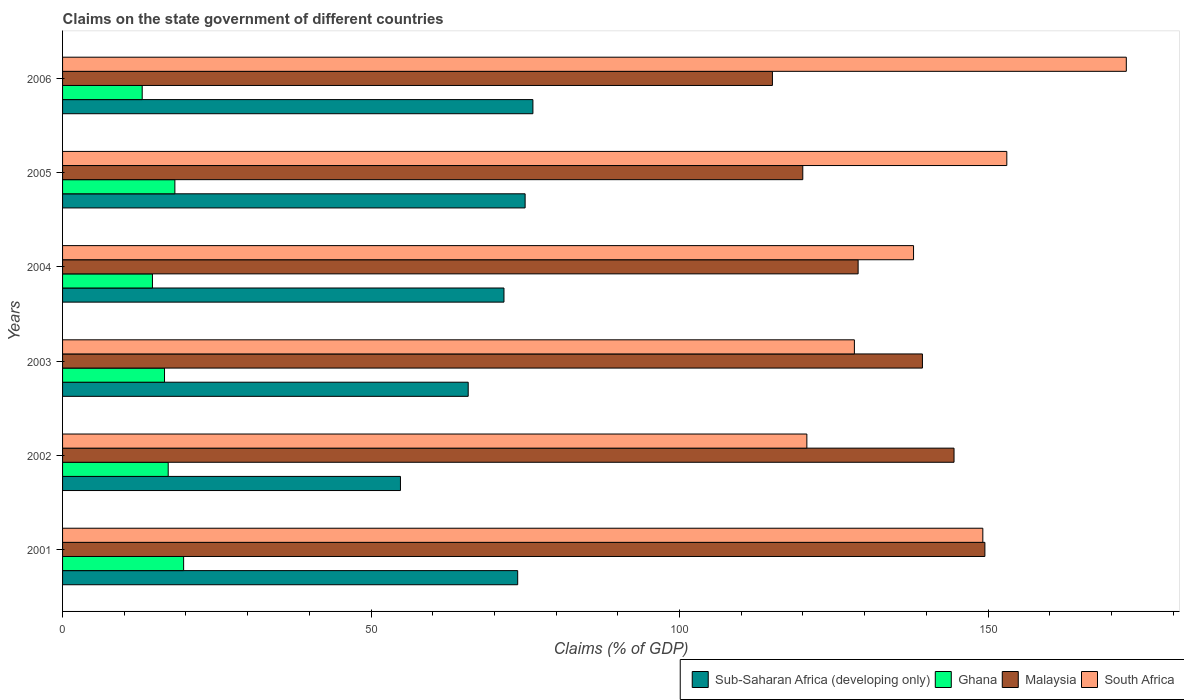Are the number of bars on each tick of the Y-axis equal?
Your answer should be very brief. Yes. How many bars are there on the 5th tick from the bottom?
Offer a terse response. 4. What is the percentage of GDP claimed on the state government in Ghana in 2001?
Your response must be concise. 19.62. Across all years, what is the maximum percentage of GDP claimed on the state government in Sub-Saharan Africa (developing only)?
Your answer should be very brief. 76.23. Across all years, what is the minimum percentage of GDP claimed on the state government in Sub-Saharan Africa (developing only)?
Give a very brief answer. 54.76. In which year was the percentage of GDP claimed on the state government in Sub-Saharan Africa (developing only) minimum?
Keep it short and to the point. 2002. What is the total percentage of GDP claimed on the state government in Sub-Saharan Africa (developing only) in the graph?
Provide a short and direct response. 417.02. What is the difference between the percentage of GDP claimed on the state government in Ghana in 2003 and that in 2004?
Your answer should be compact. 1.96. What is the difference between the percentage of GDP claimed on the state government in Sub-Saharan Africa (developing only) in 2006 and the percentage of GDP claimed on the state government in Malaysia in 2002?
Ensure brevity in your answer.  -68.26. What is the average percentage of GDP claimed on the state government in South Africa per year?
Offer a terse response. 143.58. In the year 2003, what is the difference between the percentage of GDP claimed on the state government in South Africa and percentage of GDP claimed on the state government in Malaysia?
Provide a succinct answer. -11.03. What is the ratio of the percentage of GDP claimed on the state government in Sub-Saharan Africa (developing only) in 2003 to that in 2004?
Make the answer very short. 0.92. Is the percentage of GDP claimed on the state government in Sub-Saharan Africa (developing only) in 2001 less than that in 2002?
Offer a very short reply. No. What is the difference between the highest and the second highest percentage of GDP claimed on the state government in Sub-Saharan Africa (developing only)?
Your answer should be compact. 1.26. What is the difference between the highest and the lowest percentage of GDP claimed on the state government in Ghana?
Your answer should be compact. 6.71. Is it the case that in every year, the sum of the percentage of GDP claimed on the state government in Malaysia and percentage of GDP claimed on the state government in South Africa is greater than the sum of percentage of GDP claimed on the state government in Ghana and percentage of GDP claimed on the state government in Sub-Saharan Africa (developing only)?
Give a very brief answer. No. What does the 1st bar from the top in 2002 represents?
Your answer should be compact. South Africa. What does the 4th bar from the bottom in 2004 represents?
Make the answer very short. South Africa. How many years are there in the graph?
Offer a terse response. 6. Where does the legend appear in the graph?
Ensure brevity in your answer.  Bottom right. How many legend labels are there?
Provide a short and direct response. 4. How are the legend labels stacked?
Your answer should be compact. Horizontal. What is the title of the graph?
Your answer should be very brief. Claims on the state government of different countries. Does "Moldova" appear as one of the legend labels in the graph?
Keep it short and to the point. No. What is the label or title of the X-axis?
Offer a very short reply. Claims (% of GDP). What is the label or title of the Y-axis?
Provide a succinct answer. Years. What is the Claims (% of GDP) in Sub-Saharan Africa (developing only) in 2001?
Provide a succinct answer. 73.77. What is the Claims (% of GDP) in Ghana in 2001?
Offer a terse response. 19.62. What is the Claims (% of GDP) of Malaysia in 2001?
Ensure brevity in your answer.  149.49. What is the Claims (% of GDP) of South Africa in 2001?
Make the answer very short. 149.15. What is the Claims (% of GDP) in Sub-Saharan Africa (developing only) in 2002?
Offer a terse response. 54.76. What is the Claims (% of GDP) of Ghana in 2002?
Provide a short and direct response. 17.12. What is the Claims (% of GDP) in Malaysia in 2002?
Your answer should be very brief. 144.49. What is the Claims (% of GDP) of South Africa in 2002?
Offer a very short reply. 120.63. What is the Claims (% of GDP) in Sub-Saharan Africa (developing only) in 2003?
Offer a very short reply. 65.75. What is the Claims (% of GDP) of Ghana in 2003?
Provide a succinct answer. 16.52. What is the Claims (% of GDP) in Malaysia in 2003?
Your response must be concise. 139.37. What is the Claims (% of GDP) of South Africa in 2003?
Give a very brief answer. 128.34. What is the Claims (% of GDP) in Sub-Saharan Africa (developing only) in 2004?
Your answer should be compact. 71.54. What is the Claims (% of GDP) of Ghana in 2004?
Your answer should be very brief. 14.57. What is the Claims (% of GDP) of Malaysia in 2004?
Ensure brevity in your answer.  128.94. What is the Claims (% of GDP) of South Africa in 2004?
Your answer should be compact. 137.93. What is the Claims (% of GDP) of Sub-Saharan Africa (developing only) in 2005?
Your response must be concise. 74.97. What is the Claims (% of GDP) in Ghana in 2005?
Your response must be concise. 18.2. What is the Claims (% of GDP) of Malaysia in 2005?
Your answer should be very brief. 119.97. What is the Claims (% of GDP) of South Africa in 2005?
Offer a very short reply. 153.04. What is the Claims (% of GDP) in Sub-Saharan Africa (developing only) in 2006?
Your response must be concise. 76.23. What is the Claims (% of GDP) in Ghana in 2006?
Ensure brevity in your answer.  12.91. What is the Claims (% of GDP) of Malaysia in 2006?
Offer a very short reply. 115.05. What is the Claims (% of GDP) in South Africa in 2006?
Keep it short and to the point. 172.41. Across all years, what is the maximum Claims (% of GDP) in Sub-Saharan Africa (developing only)?
Provide a short and direct response. 76.23. Across all years, what is the maximum Claims (% of GDP) in Ghana?
Your answer should be compact. 19.62. Across all years, what is the maximum Claims (% of GDP) of Malaysia?
Ensure brevity in your answer.  149.49. Across all years, what is the maximum Claims (% of GDP) of South Africa?
Offer a very short reply. 172.41. Across all years, what is the minimum Claims (% of GDP) of Sub-Saharan Africa (developing only)?
Make the answer very short. 54.76. Across all years, what is the minimum Claims (% of GDP) in Ghana?
Make the answer very short. 12.91. Across all years, what is the minimum Claims (% of GDP) in Malaysia?
Keep it short and to the point. 115.05. Across all years, what is the minimum Claims (% of GDP) in South Africa?
Ensure brevity in your answer.  120.63. What is the total Claims (% of GDP) in Sub-Saharan Africa (developing only) in the graph?
Give a very brief answer. 417.02. What is the total Claims (% of GDP) in Ghana in the graph?
Your answer should be compact. 98.95. What is the total Claims (% of GDP) in Malaysia in the graph?
Ensure brevity in your answer.  797.31. What is the total Claims (% of GDP) of South Africa in the graph?
Give a very brief answer. 861.5. What is the difference between the Claims (% of GDP) in Sub-Saharan Africa (developing only) in 2001 and that in 2002?
Make the answer very short. 19. What is the difference between the Claims (% of GDP) in Ghana in 2001 and that in 2002?
Give a very brief answer. 2.5. What is the difference between the Claims (% of GDP) of Malaysia in 2001 and that in 2002?
Offer a terse response. 5. What is the difference between the Claims (% of GDP) in South Africa in 2001 and that in 2002?
Give a very brief answer. 28.52. What is the difference between the Claims (% of GDP) of Sub-Saharan Africa (developing only) in 2001 and that in 2003?
Provide a succinct answer. 8.02. What is the difference between the Claims (% of GDP) in Ghana in 2001 and that in 2003?
Your answer should be compact. 3.1. What is the difference between the Claims (% of GDP) in Malaysia in 2001 and that in 2003?
Provide a short and direct response. 10.12. What is the difference between the Claims (% of GDP) in South Africa in 2001 and that in 2003?
Your answer should be compact. 20.82. What is the difference between the Claims (% of GDP) in Sub-Saharan Africa (developing only) in 2001 and that in 2004?
Give a very brief answer. 2.22. What is the difference between the Claims (% of GDP) of Ghana in 2001 and that in 2004?
Give a very brief answer. 5.05. What is the difference between the Claims (% of GDP) in Malaysia in 2001 and that in 2004?
Provide a short and direct response. 20.55. What is the difference between the Claims (% of GDP) in South Africa in 2001 and that in 2004?
Your answer should be compact. 11.23. What is the difference between the Claims (% of GDP) of Sub-Saharan Africa (developing only) in 2001 and that in 2005?
Provide a short and direct response. -1.2. What is the difference between the Claims (% of GDP) of Ghana in 2001 and that in 2005?
Make the answer very short. 1.42. What is the difference between the Claims (% of GDP) of Malaysia in 2001 and that in 2005?
Your answer should be compact. 29.52. What is the difference between the Claims (% of GDP) in South Africa in 2001 and that in 2005?
Your answer should be very brief. -3.89. What is the difference between the Claims (% of GDP) in Sub-Saharan Africa (developing only) in 2001 and that in 2006?
Make the answer very short. -2.47. What is the difference between the Claims (% of GDP) in Ghana in 2001 and that in 2006?
Make the answer very short. 6.71. What is the difference between the Claims (% of GDP) of Malaysia in 2001 and that in 2006?
Keep it short and to the point. 34.44. What is the difference between the Claims (% of GDP) in South Africa in 2001 and that in 2006?
Your answer should be very brief. -23.26. What is the difference between the Claims (% of GDP) in Sub-Saharan Africa (developing only) in 2002 and that in 2003?
Provide a succinct answer. -10.98. What is the difference between the Claims (% of GDP) in Ghana in 2002 and that in 2003?
Keep it short and to the point. 0.6. What is the difference between the Claims (% of GDP) of Malaysia in 2002 and that in 2003?
Your answer should be very brief. 5.12. What is the difference between the Claims (% of GDP) in South Africa in 2002 and that in 2003?
Your answer should be compact. -7.7. What is the difference between the Claims (% of GDP) in Sub-Saharan Africa (developing only) in 2002 and that in 2004?
Give a very brief answer. -16.78. What is the difference between the Claims (% of GDP) of Ghana in 2002 and that in 2004?
Your answer should be very brief. 2.55. What is the difference between the Claims (% of GDP) in Malaysia in 2002 and that in 2004?
Ensure brevity in your answer.  15.54. What is the difference between the Claims (% of GDP) in South Africa in 2002 and that in 2004?
Provide a short and direct response. -17.29. What is the difference between the Claims (% of GDP) of Sub-Saharan Africa (developing only) in 2002 and that in 2005?
Keep it short and to the point. -20.21. What is the difference between the Claims (% of GDP) of Ghana in 2002 and that in 2005?
Make the answer very short. -1.08. What is the difference between the Claims (% of GDP) in Malaysia in 2002 and that in 2005?
Your answer should be compact. 24.52. What is the difference between the Claims (% of GDP) of South Africa in 2002 and that in 2005?
Make the answer very short. -32.41. What is the difference between the Claims (% of GDP) in Sub-Saharan Africa (developing only) in 2002 and that in 2006?
Offer a terse response. -21.47. What is the difference between the Claims (% of GDP) of Ghana in 2002 and that in 2006?
Provide a short and direct response. 4.21. What is the difference between the Claims (% of GDP) of Malaysia in 2002 and that in 2006?
Provide a succinct answer. 29.44. What is the difference between the Claims (% of GDP) of South Africa in 2002 and that in 2006?
Your answer should be compact. -51.77. What is the difference between the Claims (% of GDP) of Sub-Saharan Africa (developing only) in 2003 and that in 2004?
Offer a very short reply. -5.8. What is the difference between the Claims (% of GDP) of Ghana in 2003 and that in 2004?
Ensure brevity in your answer.  1.96. What is the difference between the Claims (% of GDP) in Malaysia in 2003 and that in 2004?
Your answer should be very brief. 10.42. What is the difference between the Claims (% of GDP) in South Africa in 2003 and that in 2004?
Your answer should be compact. -9.59. What is the difference between the Claims (% of GDP) of Sub-Saharan Africa (developing only) in 2003 and that in 2005?
Provide a short and direct response. -9.22. What is the difference between the Claims (% of GDP) of Ghana in 2003 and that in 2005?
Give a very brief answer. -1.68. What is the difference between the Claims (% of GDP) of Malaysia in 2003 and that in 2005?
Ensure brevity in your answer.  19.39. What is the difference between the Claims (% of GDP) in South Africa in 2003 and that in 2005?
Give a very brief answer. -24.7. What is the difference between the Claims (% of GDP) of Sub-Saharan Africa (developing only) in 2003 and that in 2006?
Your answer should be very brief. -10.49. What is the difference between the Claims (% of GDP) in Ghana in 2003 and that in 2006?
Provide a short and direct response. 3.62. What is the difference between the Claims (% of GDP) in Malaysia in 2003 and that in 2006?
Ensure brevity in your answer.  24.31. What is the difference between the Claims (% of GDP) of South Africa in 2003 and that in 2006?
Offer a very short reply. -44.07. What is the difference between the Claims (% of GDP) in Sub-Saharan Africa (developing only) in 2004 and that in 2005?
Give a very brief answer. -3.43. What is the difference between the Claims (% of GDP) of Ghana in 2004 and that in 2005?
Provide a short and direct response. -3.63. What is the difference between the Claims (% of GDP) in Malaysia in 2004 and that in 2005?
Your response must be concise. 8.97. What is the difference between the Claims (% of GDP) in South Africa in 2004 and that in 2005?
Ensure brevity in your answer.  -15.12. What is the difference between the Claims (% of GDP) in Sub-Saharan Africa (developing only) in 2004 and that in 2006?
Make the answer very short. -4.69. What is the difference between the Claims (% of GDP) of Ghana in 2004 and that in 2006?
Your answer should be compact. 1.66. What is the difference between the Claims (% of GDP) of Malaysia in 2004 and that in 2006?
Your answer should be very brief. 13.89. What is the difference between the Claims (% of GDP) in South Africa in 2004 and that in 2006?
Your answer should be very brief. -34.48. What is the difference between the Claims (% of GDP) of Sub-Saharan Africa (developing only) in 2005 and that in 2006?
Provide a short and direct response. -1.26. What is the difference between the Claims (% of GDP) of Ghana in 2005 and that in 2006?
Your answer should be compact. 5.3. What is the difference between the Claims (% of GDP) in Malaysia in 2005 and that in 2006?
Ensure brevity in your answer.  4.92. What is the difference between the Claims (% of GDP) of South Africa in 2005 and that in 2006?
Keep it short and to the point. -19.37. What is the difference between the Claims (% of GDP) of Sub-Saharan Africa (developing only) in 2001 and the Claims (% of GDP) of Ghana in 2002?
Make the answer very short. 56.64. What is the difference between the Claims (% of GDP) of Sub-Saharan Africa (developing only) in 2001 and the Claims (% of GDP) of Malaysia in 2002?
Make the answer very short. -70.72. What is the difference between the Claims (% of GDP) of Sub-Saharan Africa (developing only) in 2001 and the Claims (% of GDP) of South Africa in 2002?
Offer a very short reply. -46.87. What is the difference between the Claims (% of GDP) of Ghana in 2001 and the Claims (% of GDP) of Malaysia in 2002?
Offer a terse response. -124.87. What is the difference between the Claims (% of GDP) of Ghana in 2001 and the Claims (% of GDP) of South Africa in 2002?
Provide a succinct answer. -101.01. What is the difference between the Claims (% of GDP) in Malaysia in 2001 and the Claims (% of GDP) in South Africa in 2002?
Your answer should be compact. 28.85. What is the difference between the Claims (% of GDP) of Sub-Saharan Africa (developing only) in 2001 and the Claims (% of GDP) of Ghana in 2003?
Your answer should be compact. 57.24. What is the difference between the Claims (% of GDP) in Sub-Saharan Africa (developing only) in 2001 and the Claims (% of GDP) in Malaysia in 2003?
Provide a succinct answer. -65.6. What is the difference between the Claims (% of GDP) of Sub-Saharan Africa (developing only) in 2001 and the Claims (% of GDP) of South Africa in 2003?
Give a very brief answer. -54.57. What is the difference between the Claims (% of GDP) of Ghana in 2001 and the Claims (% of GDP) of Malaysia in 2003?
Keep it short and to the point. -119.75. What is the difference between the Claims (% of GDP) in Ghana in 2001 and the Claims (% of GDP) in South Africa in 2003?
Make the answer very short. -108.72. What is the difference between the Claims (% of GDP) of Malaysia in 2001 and the Claims (% of GDP) of South Africa in 2003?
Make the answer very short. 21.15. What is the difference between the Claims (% of GDP) in Sub-Saharan Africa (developing only) in 2001 and the Claims (% of GDP) in Ghana in 2004?
Give a very brief answer. 59.2. What is the difference between the Claims (% of GDP) of Sub-Saharan Africa (developing only) in 2001 and the Claims (% of GDP) of Malaysia in 2004?
Your response must be concise. -55.18. What is the difference between the Claims (% of GDP) of Sub-Saharan Africa (developing only) in 2001 and the Claims (% of GDP) of South Africa in 2004?
Keep it short and to the point. -64.16. What is the difference between the Claims (% of GDP) in Ghana in 2001 and the Claims (% of GDP) in Malaysia in 2004?
Offer a very short reply. -109.32. What is the difference between the Claims (% of GDP) in Ghana in 2001 and the Claims (% of GDP) in South Africa in 2004?
Offer a very short reply. -118.31. What is the difference between the Claims (% of GDP) in Malaysia in 2001 and the Claims (% of GDP) in South Africa in 2004?
Provide a short and direct response. 11.56. What is the difference between the Claims (% of GDP) of Sub-Saharan Africa (developing only) in 2001 and the Claims (% of GDP) of Ghana in 2005?
Your answer should be compact. 55.56. What is the difference between the Claims (% of GDP) of Sub-Saharan Africa (developing only) in 2001 and the Claims (% of GDP) of Malaysia in 2005?
Make the answer very short. -46.21. What is the difference between the Claims (% of GDP) of Sub-Saharan Africa (developing only) in 2001 and the Claims (% of GDP) of South Africa in 2005?
Ensure brevity in your answer.  -79.28. What is the difference between the Claims (% of GDP) in Ghana in 2001 and the Claims (% of GDP) in Malaysia in 2005?
Your answer should be compact. -100.35. What is the difference between the Claims (% of GDP) in Ghana in 2001 and the Claims (% of GDP) in South Africa in 2005?
Provide a short and direct response. -133.42. What is the difference between the Claims (% of GDP) in Malaysia in 2001 and the Claims (% of GDP) in South Africa in 2005?
Provide a short and direct response. -3.55. What is the difference between the Claims (% of GDP) of Sub-Saharan Africa (developing only) in 2001 and the Claims (% of GDP) of Ghana in 2006?
Your response must be concise. 60.86. What is the difference between the Claims (% of GDP) of Sub-Saharan Africa (developing only) in 2001 and the Claims (% of GDP) of Malaysia in 2006?
Keep it short and to the point. -41.29. What is the difference between the Claims (% of GDP) in Sub-Saharan Africa (developing only) in 2001 and the Claims (% of GDP) in South Africa in 2006?
Make the answer very short. -98.64. What is the difference between the Claims (% of GDP) in Ghana in 2001 and the Claims (% of GDP) in Malaysia in 2006?
Provide a short and direct response. -95.43. What is the difference between the Claims (% of GDP) in Ghana in 2001 and the Claims (% of GDP) in South Africa in 2006?
Make the answer very short. -152.79. What is the difference between the Claims (% of GDP) in Malaysia in 2001 and the Claims (% of GDP) in South Africa in 2006?
Give a very brief answer. -22.92. What is the difference between the Claims (% of GDP) of Sub-Saharan Africa (developing only) in 2002 and the Claims (% of GDP) of Ghana in 2003?
Offer a terse response. 38.24. What is the difference between the Claims (% of GDP) in Sub-Saharan Africa (developing only) in 2002 and the Claims (% of GDP) in Malaysia in 2003?
Offer a terse response. -84.6. What is the difference between the Claims (% of GDP) of Sub-Saharan Africa (developing only) in 2002 and the Claims (% of GDP) of South Africa in 2003?
Your response must be concise. -73.57. What is the difference between the Claims (% of GDP) in Ghana in 2002 and the Claims (% of GDP) in Malaysia in 2003?
Your response must be concise. -122.24. What is the difference between the Claims (% of GDP) of Ghana in 2002 and the Claims (% of GDP) of South Africa in 2003?
Your answer should be compact. -111.22. What is the difference between the Claims (% of GDP) in Malaysia in 2002 and the Claims (% of GDP) in South Africa in 2003?
Offer a very short reply. 16.15. What is the difference between the Claims (% of GDP) of Sub-Saharan Africa (developing only) in 2002 and the Claims (% of GDP) of Ghana in 2004?
Provide a short and direct response. 40.2. What is the difference between the Claims (% of GDP) of Sub-Saharan Africa (developing only) in 2002 and the Claims (% of GDP) of Malaysia in 2004?
Provide a short and direct response. -74.18. What is the difference between the Claims (% of GDP) of Sub-Saharan Africa (developing only) in 2002 and the Claims (% of GDP) of South Africa in 2004?
Offer a terse response. -83.16. What is the difference between the Claims (% of GDP) of Ghana in 2002 and the Claims (% of GDP) of Malaysia in 2004?
Your answer should be very brief. -111.82. What is the difference between the Claims (% of GDP) in Ghana in 2002 and the Claims (% of GDP) in South Africa in 2004?
Keep it short and to the point. -120.8. What is the difference between the Claims (% of GDP) in Malaysia in 2002 and the Claims (% of GDP) in South Africa in 2004?
Give a very brief answer. 6.56. What is the difference between the Claims (% of GDP) in Sub-Saharan Africa (developing only) in 2002 and the Claims (% of GDP) in Ghana in 2005?
Offer a very short reply. 36.56. What is the difference between the Claims (% of GDP) of Sub-Saharan Africa (developing only) in 2002 and the Claims (% of GDP) of Malaysia in 2005?
Offer a very short reply. -65.21. What is the difference between the Claims (% of GDP) of Sub-Saharan Africa (developing only) in 2002 and the Claims (% of GDP) of South Africa in 2005?
Your answer should be very brief. -98.28. What is the difference between the Claims (% of GDP) in Ghana in 2002 and the Claims (% of GDP) in Malaysia in 2005?
Your answer should be compact. -102.85. What is the difference between the Claims (% of GDP) of Ghana in 2002 and the Claims (% of GDP) of South Africa in 2005?
Offer a terse response. -135.92. What is the difference between the Claims (% of GDP) in Malaysia in 2002 and the Claims (% of GDP) in South Africa in 2005?
Give a very brief answer. -8.56. What is the difference between the Claims (% of GDP) in Sub-Saharan Africa (developing only) in 2002 and the Claims (% of GDP) in Ghana in 2006?
Your response must be concise. 41.86. What is the difference between the Claims (% of GDP) of Sub-Saharan Africa (developing only) in 2002 and the Claims (% of GDP) of Malaysia in 2006?
Your answer should be compact. -60.29. What is the difference between the Claims (% of GDP) in Sub-Saharan Africa (developing only) in 2002 and the Claims (% of GDP) in South Africa in 2006?
Offer a very short reply. -117.65. What is the difference between the Claims (% of GDP) of Ghana in 2002 and the Claims (% of GDP) of Malaysia in 2006?
Your answer should be compact. -97.93. What is the difference between the Claims (% of GDP) in Ghana in 2002 and the Claims (% of GDP) in South Africa in 2006?
Your answer should be very brief. -155.29. What is the difference between the Claims (% of GDP) in Malaysia in 2002 and the Claims (% of GDP) in South Africa in 2006?
Provide a short and direct response. -27.92. What is the difference between the Claims (% of GDP) of Sub-Saharan Africa (developing only) in 2003 and the Claims (% of GDP) of Ghana in 2004?
Make the answer very short. 51.18. What is the difference between the Claims (% of GDP) of Sub-Saharan Africa (developing only) in 2003 and the Claims (% of GDP) of Malaysia in 2004?
Your answer should be very brief. -63.2. What is the difference between the Claims (% of GDP) in Sub-Saharan Africa (developing only) in 2003 and the Claims (% of GDP) in South Africa in 2004?
Make the answer very short. -72.18. What is the difference between the Claims (% of GDP) of Ghana in 2003 and the Claims (% of GDP) of Malaysia in 2004?
Your answer should be very brief. -112.42. What is the difference between the Claims (% of GDP) of Ghana in 2003 and the Claims (% of GDP) of South Africa in 2004?
Give a very brief answer. -121.4. What is the difference between the Claims (% of GDP) of Malaysia in 2003 and the Claims (% of GDP) of South Africa in 2004?
Keep it short and to the point. 1.44. What is the difference between the Claims (% of GDP) in Sub-Saharan Africa (developing only) in 2003 and the Claims (% of GDP) in Ghana in 2005?
Provide a succinct answer. 47.54. What is the difference between the Claims (% of GDP) in Sub-Saharan Africa (developing only) in 2003 and the Claims (% of GDP) in Malaysia in 2005?
Provide a short and direct response. -54.23. What is the difference between the Claims (% of GDP) in Sub-Saharan Africa (developing only) in 2003 and the Claims (% of GDP) in South Africa in 2005?
Your answer should be compact. -87.3. What is the difference between the Claims (% of GDP) in Ghana in 2003 and the Claims (% of GDP) in Malaysia in 2005?
Your response must be concise. -103.45. What is the difference between the Claims (% of GDP) in Ghana in 2003 and the Claims (% of GDP) in South Africa in 2005?
Offer a terse response. -136.52. What is the difference between the Claims (% of GDP) of Malaysia in 2003 and the Claims (% of GDP) of South Africa in 2005?
Offer a very short reply. -13.68. What is the difference between the Claims (% of GDP) in Sub-Saharan Africa (developing only) in 2003 and the Claims (% of GDP) in Ghana in 2006?
Provide a short and direct response. 52.84. What is the difference between the Claims (% of GDP) of Sub-Saharan Africa (developing only) in 2003 and the Claims (% of GDP) of Malaysia in 2006?
Offer a terse response. -49.31. What is the difference between the Claims (% of GDP) of Sub-Saharan Africa (developing only) in 2003 and the Claims (% of GDP) of South Africa in 2006?
Make the answer very short. -106.66. What is the difference between the Claims (% of GDP) of Ghana in 2003 and the Claims (% of GDP) of Malaysia in 2006?
Your answer should be compact. -98.53. What is the difference between the Claims (% of GDP) in Ghana in 2003 and the Claims (% of GDP) in South Africa in 2006?
Make the answer very short. -155.88. What is the difference between the Claims (% of GDP) of Malaysia in 2003 and the Claims (% of GDP) of South Africa in 2006?
Give a very brief answer. -33.04. What is the difference between the Claims (% of GDP) of Sub-Saharan Africa (developing only) in 2004 and the Claims (% of GDP) of Ghana in 2005?
Your response must be concise. 53.34. What is the difference between the Claims (% of GDP) in Sub-Saharan Africa (developing only) in 2004 and the Claims (% of GDP) in Malaysia in 2005?
Offer a very short reply. -48.43. What is the difference between the Claims (% of GDP) of Sub-Saharan Africa (developing only) in 2004 and the Claims (% of GDP) of South Africa in 2005?
Your response must be concise. -81.5. What is the difference between the Claims (% of GDP) in Ghana in 2004 and the Claims (% of GDP) in Malaysia in 2005?
Provide a short and direct response. -105.4. What is the difference between the Claims (% of GDP) in Ghana in 2004 and the Claims (% of GDP) in South Africa in 2005?
Provide a succinct answer. -138.47. What is the difference between the Claims (% of GDP) in Malaysia in 2004 and the Claims (% of GDP) in South Africa in 2005?
Give a very brief answer. -24.1. What is the difference between the Claims (% of GDP) in Sub-Saharan Africa (developing only) in 2004 and the Claims (% of GDP) in Ghana in 2006?
Your response must be concise. 58.63. What is the difference between the Claims (% of GDP) of Sub-Saharan Africa (developing only) in 2004 and the Claims (% of GDP) of Malaysia in 2006?
Provide a short and direct response. -43.51. What is the difference between the Claims (% of GDP) in Sub-Saharan Africa (developing only) in 2004 and the Claims (% of GDP) in South Africa in 2006?
Give a very brief answer. -100.87. What is the difference between the Claims (% of GDP) of Ghana in 2004 and the Claims (% of GDP) of Malaysia in 2006?
Keep it short and to the point. -100.48. What is the difference between the Claims (% of GDP) in Ghana in 2004 and the Claims (% of GDP) in South Africa in 2006?
Offer a very short reply. -157.84. What is the difference between the Claims (% of GDP) in Malaysia in 2004 and the Claims (% of GDP) in South Africa in 2006?
Offer a terse response. -43.47. What is the difference between the Claims (% of GDP) of Sub-Saharan Africa (developing only) in 2005 and the Claims (% of GDP) of Ghana in 2006?
Your answer should be compact. 62.06. What is the difference between the Claims (% of GDP) in Sub-Saharan Africa (developing only) in 2005 and the Claims (% of GDP) in Malaysia in 2006?
Provide a short and direct response. -40.08. What is the difference between the Claims (% of GDP) in Sub-Saharan Africa (developing only) in 2005 and the Claims (% of GDP) in South Africa in 2006?
Offer a terse response. -97.44. What is the difference between the Claims (% of GDP) of Ghana in 2005 and the Claims (% of GDP) of Malaysia in 2006?
Keep it short and to the point. -96.85. What is the difference between the Claims (% of GDP) in Ghana in 2005 and the Claims (% of GDP) in South Africa in 2006?
Provide a short and direct response. -154.21. What is the difference between the Claims (% of GDP) in Malaysia in 2005 and the Claims (% of GDP) in South Africa in 2006?
Give a very brief answer. -52.44. What is the average Claims (% of GDP) of Sub-Saharan Africa (developing only) per year?
Provide a short and direct response. 69.5. What is the average Claims (% of GDP) in Ghana per year?
Make the answer very short. 16.49. What is the average Claims (% of GDP) in Malaysia per year?
Your response must be concise. 132.88. What is the average Claims (% of GDP) in South Africa per year?
Give a very brief answer. 143.58. In the year 2001, what is the difference between the Claims (% of GDP) in Sub-Saharan Africa (developing only) and Claims (% of GDP) in Ghana?
Keep it short and to the point. 54.15. In the year 2001, what is the difference between the Claims (% of GDP) in Sub-Saharan Africa (developing only) and Claims (% of GDP) in Malaysia?
Make the answer very short. -75.72. In the year 2001, what is the difference between the Claims (% of GDP) in Sub-Saharan Africa (developing only) and Claims (% of GDP) in South Africa?
Ensure brevity in your answer.  -75.39. In the year 2001, what is the difference between the Claims (% of GDP) in Ghana and Claims (% of GDP) in Malaysia?
Keep it short and to the point. -129.87. In the year 2001, what is the difference between the Claims (% of GDP) in Ghana and Claims (% of GDP) in South Africa?
Offer a very short reply. -129.53. In the year 2001, what is the difference between the Claims (% of GDP) in Malaysia and Claims (% of GDP) in South Africa?
Your response must be concise. 0.33. In the year 2002, what is the difference between the Claims (% of GDP) of Sub-Saharan Africa (developing only) and Claims (% of GDP) of Ghana?
Your response must be concise. 37.64. In the year 2002, what is the difference between the Claims (% of GDP) of Sub-Saharan Africa (developing only) and Claims (% of GDP) of Malaysia?
Your response must be concise. -89.72. In the year 2002, what is the difference between the Claims (% of GDP) of Sub-Saharan Africa (developing only) and Claims (% of GDP) of South Africa?
Make the answer very short. -65.87. In the year 2002, what is the difference between the Claims (% of GDP) in Ghana and Claims (% of GDP) in Malaysia?
Give a very brief answer. -127.37. In the year 2002, what is the difference between the Claims (% of GDP) in Ghana and Claims (% of GDP) in South Africa?
Provide a succinct answer. -103.51. In the year 2002, what is the difference between the Claims (% of GDP) of Malaysia and Claims (% of GDP) of South Africa?
Provide a succinct answer. 23.85. In the year 2003, what is the difference between the Claims (% of GDP) of Sub-Saharan Africa (developing only) and Claims (% of GDP) of Ghana?
Your response must be concise. 49.22. In the year 2003, what is the difference between the Claims (% of GDP) of Sub-Saharan Africa (developing only) and Claims (% of GDP) of Malaysia?
Give a very brief answer. -73.62. In the year 2003, what is the difference between the Claims (% of GDP) of Sub-Saharan Africa (developing only) and Claims (% of GDP) of South Africa?
Give a very brief answer. -62.59. In the year 2003, what is the difference between the Claims (% of GDP) of Ghana and Claims (% of GDP) of Malaysia?
Ensure brevity in your answer.  -122.84. In the year 2003, what is the difference between the Claims (% of GDP) of Ghana and Claims (% of GDP) of South Africa?
Provide a short and direct response. -111.81. In the year 2003, what is the difference between the Claims (% of GDP) of Malaysia and Claims (% of GDP) of South Africa?
Make the answer very short. 11.03. In the year 2004, what is the difference between the Claims (% of GDP) in Sub-Saharan Africa (developing only) and Claims (% of GDP) in Ghana?
Your answer should be very brief. 56.97. In the year 2004, what is the difference between the Claims (% of GDP) in Sub-Saharan Africa (developing only) and Claims (% of GDP) in Malaysia?
Provide a succinct answer. -57.4. In the year 2004, what is the difference between the Claims (% of GDP) in Sub-Saharan Africa (developing only) and Claims (% of GDP) in South Africa?
Provide a succinct answer. -66.39. In the year 2004, what is the difference between the Claims (% of GDP) of Ghana and Claims (% of GDP) of Malaysia?
Give a very brief answer. -114.38. In the year 2004, what is the difference between the Claims (% of GDP) in Ghana and Claims (% of GDP) in South Africa?
Make the answer very short. -123.36. In the year 2004, what is the difference between the Claims (% of GDP) in Malaysia and Claims (% of GDP) in South Africa?
Make the answer very short. -8.98. In the year 2005, what is the difference between the Claims (% of GDP) of Sub-Saharan Africa (developing only) and Claims (% of GDP) of Ghana?
Offer a very short reply. 56.77. In the year 2005, what is the difference between the Claims (% of GDP) of Sub-Saharan Africa (developing only) and Claims (% of GDP) of Malaysia?
Make the answer very short. -45. In the year 2005, what is the difference between the Claims (% of GDP) of Sub-Saharan Africa (developing only) and Claims (% of GDP) of South Africa?
Offer a very short reply. -78.07. In the year 2005, what is the difference between the Claims (% of GDP) in Ghana and Claims (% of GDP) in Malaysia?
Your answer should be compact. -101.77. In the year 2005, what is the difference between the Claims (% of GDP) in Ghana and Claims (% of GDP) in South Africa?
Your answer should be compact. -134.84. In the year 2005, what is the difference between the Claims (% of GDP) in Malaysia and Claims (% of GDP) in South Africa?
Provide a short and direct response. -33.07. In the year 2006, what is the difference between the Claims (% of GDP) of Sub-Saharan Africa (developing only) and Claims (% of GDP) of Ghana?
Your answer should be very brief. 63.32. In the year 2006, what is the difference between the Claims (% of GDP) in Sub-Saharan Africa (developing only) and Claims (% of GDP) in Malaysia?
Your answer should be very brief. -38.82. In the year 2006, what is the difference between the Claims (% of GDP) of Sub-Saharan Africa (developing only) and Claims (% of GDP) of South Africa?
Ensure brevity in your answer.  -96.18. In the year 2006, what is the difference between the Claims (% of GDP) of Ghana and Claims (% of GDP) of Malaysia?
Offer a terse response. -102.14. In the year 2006, what is the difference between the Claims (% of GDP) in Ghana and Claims (% of GDP) in South Africa?
Offer a terse response. -159.5. In the year 2006, what is the difference between the Claims (% of GDP) in Malaysia and Claims (% of GDP) in South Africa?
Make the answer very short. -57.36. What is the ratio of the Claims (% of GDP) of Sub-Saharan Africa (developing only) in 2001 to that in 2002?
Make the answer very short. 1.35. What is the ratio of the Claims (% of GDP) of Ghana in 2001 to that in 2002?
Give a very brief answer. 1.15. What is the ratio of the Claims (% of GDP) in Malaysia in 2001 to that in 2002?
Offer a very short reply. 1.03. What is the ratio of the Claims (% of GDP) of South Africa in 2001 to that in 2002?
Provide a succinct answer. 1.24. What is the ratio of the Claims (% of GDP) of Sub-Saharan Africa (developing only) in 2001 to that in 2003?
Provide a succinct answer. 1.12. What is the ratio of the Claims (% of GDP) in Ghana in 2001 to that in 2003?
Keep it short and to the point. 1.19. What is the ratio of the Claims (% of GDP) in Malaysia in 2001 to that in 2003?
Give a very brief answer. 1.07. What is the ratio of the Claims (% of GDP) in South Africa in 2001 to that in 2003?
Ensure brevity in your answer.  1.16. What is the ratio of the Claims (% of GDP) of Sub-Saharan Africa (developing only) in 2001 to that in 2004?
Offer a very short reply. 1.03. What is the ratio of the Claims (% of GDP) of Ghana in 2001 to that in 2004?
Your answer should be compact. 1.35. What is the ratio of the Claims (% of GDP) of Malaysia in 2001 to that in 2004?
Your response must be concise. 1.16. What is the ratio of the Claims (% of GDP) of South Africa in 2001 to that in 2004?
Provide a succinct answer. 1.08. What is the ratio of the Claims (% of GDP) in Sub-Saharan Africa (developing only) in 2001 to that in 2005?
Keep it short and to the point. 0.98. What is the ratio of the Claims (% of GDP) in Ghana in 2001 to that in 2005?
Give a very brief answer. 1.08. What is the ratio of the Claims (% of GDP) of Malaysia in 2001 to that in 2005?
Your response must be concise. 1.25. What is the ratio of the Claims (% of GDP) of South Africa in 2001 to that in 2005?
Give a very brief answer. 0.97. What is the ratio of the Claims (% of GDP) of Ghana in 2001 to that in 2006?
Provide a succinct answer. 1.52. What is the ratio of the Claims (% of GDP) in Malaysia in 2001 to that in 2006?
Keep it short and to the point. 1.3. What is the ratio of the Claims (% of GDP) in South Africa in 2001 to that in 2006?
Ensure brevity in your answer.  0.87. What is the ratio of the Claims (% of GDP) of Sub-Saharan Africa (developing only) in 2002 to that in 2003?
Ensure brevity in your answer.  0.83. What is the ratio of the Claims (% of GDP) in Ghana in 2002 to that in 2003?
Give a very brief answer. 1.04. What is the ratio of the Claims (% of GDP) in Malaysia in 2002 to that in 2003?
Give a very brief answer. 1.04. What is the ratio of the Claims (% of GDP) in Sub-Saharan Africa (developing only) in 2002 to that in 2004?
Offer a very short reply. 0.77. What is the ratio of the Claims (% of GDP) in Ghana in 2002 to that in 2004?
Make the answer very short. 1.18. What is the ratio of the Claims (% of GDP) in Malaysia in 2002 to that in 2004?
Ensure brevity in your answer.  1.12. What is the ratio of the Claims (% of GDP) of South Africa in 2002 to that in 2004?
Offer a very short reply. 0.87. What is the ratio of the Claims (% of GDP) in Sub-Saharan Africa (developing only) in 2002 to that in 2005?
Give a very brief answer. 0.73. What is the ratio of the Claims (% of GDP) in Ghana in 2002 to that in 2005?
Offer a terse response. 0.94. What is the ratio of the Claims (% of GDP) of Malaysia in 2002 to that in 2005?
Keep it short and to the point. 1.2. What is the ratio of the Claims (% of GDP) of South Africa in 2002 to that in 2005?
Give a very brief answer. 0.79. What is the ratio of the Claims (% of GDP) in Sub-Saharan Africa (developing only) in 2002 to that in 2006?
Your answer should be very brief. 0.72. What is the ratio of the Claims (% of GDP) in Ghana in 2002 to that in 2006?
Make the answer very short. 1.33. What is the ratio of the Claims (% of GDP) in Malaysia in 2002 to that in 2006?
Keep it short and to the point. 1.26. What is the ratio of the Claims (% of GDP) of South Africa in 2002 to that in 2006?
Keep it short and to the point. 0.7. What is the ratio of the Claims (% of GDP) of Sub-Saharan Africa (developing only) in 2003 to that in 2004?
Your answer should be very brief. 0.92. What is the ratio of the Claims (% of GDP) of Ghana in 2003 to that in 2004?
Your response must be concise. 1.13. What is the ratio of the Claims (% of GDP) of Malaysia in 2003 to that in 2004?
Make the answer very short. 1.08. What is the ratio of the Claims (% of GDP) in South Africa in 2003 to that in 2004?
Offer a very short reply. 0.93. What is the ratio of the Claims (% of GDP) in Sub-Saharan Africa (developing only) in 2003 to that in 2005?
Provide a succinct answer. 0.88. What is the ratio of the Claims (% of GDP) in Ghana in 2003 to that in 2005?
Your answer should be very brief. 0.91. What is the ratio of the Claims (% of GDP) in Malaysia in 2003 to that in 2005?
Make the answer very short. 1.16. What is the ratio of the Claims (% of GDP) of South Africa in 2003 to that in 2005?
Make the answer very short. 0.84. What is the ratio of the Claims (% of GDP) in Sub-Saharan Africa (developing only) in 2003 to that in 2006?
Your answer should be compact. 0.86. What is the ratio of the Claims (% of GDP) in Ghana in 2003 to that in 2006?
Provide a short and direct response. 1.28. What is the ratio of the Claims (% of GDP) in Malaysia in 2003 to that in 2006?
Your answer should be compact. 1.21. What is the ratio of the Claims (% of GDP) of South Africa in 2003 to that in 2006?
Offer a very short reply. 0.74. What is the ratio of the Claims (% of GDP) of Sub-Saharan Africa (developing only) in 2004 to that in 2005?
Keep it short and to the point. 0.95. What is the ratio of the Claims (% of GDP) of Ghana in 2004 to that in 2005?
Give a very brief answer. 0.8. What is the ratio of the Claims (% of GDP) of Malaysia in 2004 to that in 2005?
Your response must be concise. 1.07. What is the ratio of the Claims (% of GDP) of South Africa in 2004 to that in 2005?
Make the answer very short. 0.9. What is the ratio of the Claims (% of GDP) in Sub-Saharan Africa (developing only) in 2004 to that in 2006?
Make the answer very short. 0.94. What is the ratio of the Claims (% of GDP) of Ghana in 2004 to that in 2006?
Ensure brevity in your answer.  1.13. What is the ratio of the Claims (% of GDP) in Malaysia in 2004 to that in 2006?
Offer a terse response. 1.12. What is the ratio of the Claims (% of GDP) of Sub-Saharan Africa (developing only) in 2005 to that in 2006?
Make the answer very short. 0.98. What is the ratio of the Claims (% of GDP) in Ghana in 2005 to that in 2006?
Make the answer very short. 1.41. What is the ratio of the Claims (% of GDP) of Malaysia in 2005 to that in 2006?
Give a very brief answer. 1.04. What is the ratio of the Claims (% of GDP) of South Africa in 2005 to that in 2006?
Give a very brief answer. 0.89. What is the difference between the highest and the second highest Claims (% of GDP) in Sub-Saharan Africa (developing only)?
Provide a short and direct response. 1.26. What is the difference between the highest and the second highest Claims (% of GDP) of Ghana?
Offer a very short reply. 1.42. What is the difference between the highest and the second highest Claims (% of GDP) in Malaysia?
Your answer should be compact. 5. What is the difference between the highest and the second highest Claims (% of GDP) in South Africa?
Give a very brief answer. 19.37. What is the difference between the highest and the lowest Claims (% of GDP) in Sub-Saharan Africa (developing only)?
Your answer should be compact. 21.47. What is the difference between the highest and the lowest Claims (% of GDP) of Ghana?
Provide a succinct answer. 6.71. What is the difference between the highest and the lowest Claims (% of GDP) in Malaysia?
Your answer should be very brief. 34.44. What is the difference between the highest and the lowest Claims (% of GDP) of South Africa?
Provide a succinct answer. 51.77. 